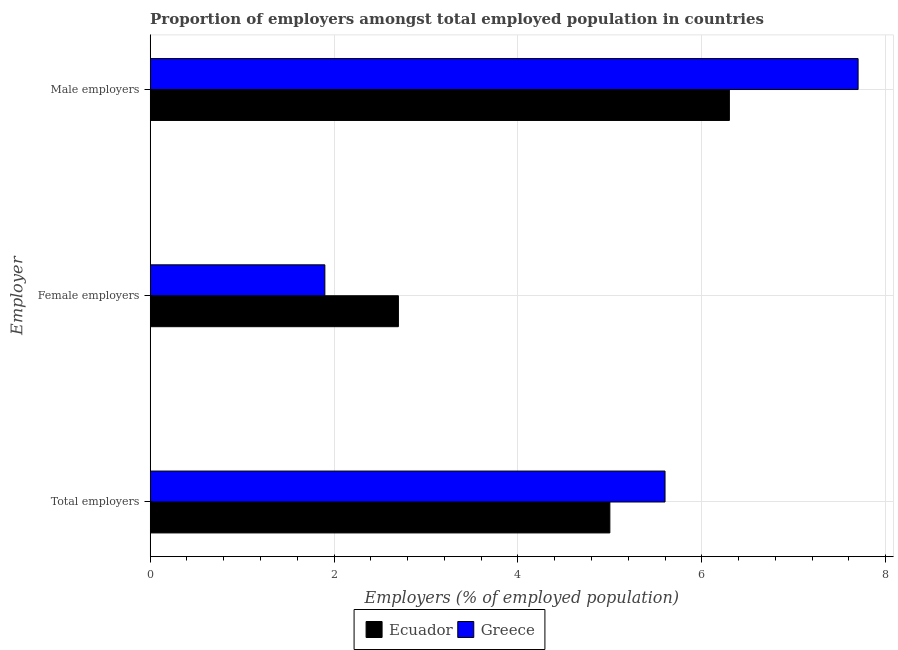How many bars are there on the 2nd tick from the top?
Provide a short and direct response. 2. What is the label of the 1st group of bars from the top?
Give a very brief answer. Male employers. Across all countries, what is the maximum percentage of female employers?
Ensure brevity in your answer.  2.7. In which country was the percentage of male employers maximum?
Ensure brevity in your answer.  Greece. In which country was the percentage of female employers minimum?
Offer a very short reply. Greece. What is the total percentage of male employers in the graph?
Offer a terse response. 14. What is the difference between the percentage of total employers in Greece and that in Ecuador?
Your answer should be compact. 0.6. What is the difference between the percentage of male employers in Greece and the percentage of female employers in Ecuador?
Make the answer very short. 5. What is the average percentage of total employers per country?
Offer a very short reply. 5.3. What is the difference between the percentage of female employers and percentage of total employers in Greece?
Your answer should be compact. -3.7. What is the ratio of the percentage of female employers in Ecuador to that in Greece?
Keep it short and to the point. 1.42. What is the difference between the highest and the second highest percentage of male employers?
Your answer should be very brief. 1.4. What is the difference between the highest and the lowest percentage of male employers?
Your answer should be compact. 1.4. In how many countries, is the percentage of male employers greater than the average percentage of male employers taken over all countries?
Your response must be concise. 1. Is the sum of the percentage of female employers in Greece and Ecuador greater than the maximum percentage of total employers across all countries?
Keep it short and to the point. No. What does the 2nd bar from the top in Male employers represents?
Provide a short and direct response. Ecuador. How many bars are there?
Provide a short and direct response. 6. Are all the bars in the graph horizontal?
Keep it short and to the point. Yes. Does the graph contain grids?
Make the answer very short. Yes. Where does the legend appear in the graph?
Make the answer very short. Bottom center. How many legend labels are there?
Ensure brevity in your answer.  2. How are the legend labels stacked?
Provide a succinct answer. Horizontal. What is the title of the graph?
Your answer should be very brief. Proportion of employers amongst total employed population in countries. Does "Portugal" appear as one of the legend labels in the graph?
Make the answer very short. No. What is the label or title of the X-axis?
Give a very brief answer. Employers (% of employed population). What is the label or title of the Y-axis?
Your answer should be compact. Employer. What is the Employers (% of employed population) of Ecuador in Total employers?
Offer a very short reply. 5. What is the Employers (% of employed population) in Greece in Total employers?
Provide a short and direct response. 5.6. What is the Employers (% of employed population) in Ecuador in Female employers?
Make the answer very short. 2.7. What is the Employers (% of employed population) in Greece in Female employers?
Provide a succinct answer. 1.9. What is the Employers (% of employed population) in Ecuador in Male employers?
Offer a very short reply. 6.3. What is the Employers (% of employed population) in Greece in Male employers?
Make the answer very short. 7.7. Across all Employer, what is the maximum Employers (% of employed population) in Ecuador?
Your answer should be compact. 6.3. Across all Employer, what is the maximum Employers (% of employed population) in Greece?
Make the answer very short. 7.7. Across all Employer, what is the minimum Employers (% of employed population) of Ecuador?
Ensure brevity in your answer.  2.7. Across all Employer, what is the minimum Employers (% of employed population) of Greece?
Give a very brief answer. 1.9. What is the total Employers (% of employed population) of Ecuador in the graph?
Give a very brief answer. 14. What is the difference between the Employers (% of employed population) in Ecuador in Total employers and that in Female employers?
Your answer should be very brief. 2.3. What is the difference between the Employers (% of employed population) of Greece in Total employers and that in Female employers?
Provide a short and direct response. 3.7. What is the difference between the Employers (% of employed population) in Ecuador in Total employers and that in Male employers?
Your answer should be very brief. -1.3. What is the difference between the Employers (% of employed population) of Greece in Total employers and that in Male employers?
Offer a terse response. -2.1. What is the difference between the Employers (% of employed population) in Ecuador in Female employers and that in Male employers?
Make the answer very short. -3.6. What is the difference between the Employers (% of employed population) in Greece in Female employers and that in Male employers?
Your response must be concise. -5.8. What is the average Employers (% of employed population) of Ecuador per Employer?
Your answer should be compact. 4.67. What is the average Employers (% of employed population) of Greece per Employer?
Your response must be concise. 5.07. What is the ratio of the Employers (% of employed population) of Ecuador in Total employers to that in Female employers?
Provide a succinct answer. 1.85. What is the ratio of the Employers (% of employed population) in Greece in Total employers to that in Female employers?
Provide a succinct answer. 2.95. What is the ratio of the Employers (% of employed population) of Ecuador in Total employers to that in Male employers?
Ensure brevity in your answer.  0.79. What is the ratio of the Employers (% of employed population) in Greece in Total employers to that in Male employers?
Offer a very short reply. 0.73. What is the ratio of the Employers (% of employed population) of Ecuador in Female employers to that in Male employers?
Keep it short and to the point. 0.43. What is the ratio of the Employers (% of employed population) of Greece in Female employers to that in Male employers?
Your response must be concise. 0.25. What is the difference between the highest and the second highest Employers (% of employed population) of Greece?
Your answer should be very brief. 2.1. What is the difference between the highest and the lowest Employers (% of employed population) of Ecuador?
Provide a succinct answer. 3.6. What is the difference between the highest and the lowest Employers (% of employed population) in Greece?
Give a very brief answer. 5.8. 